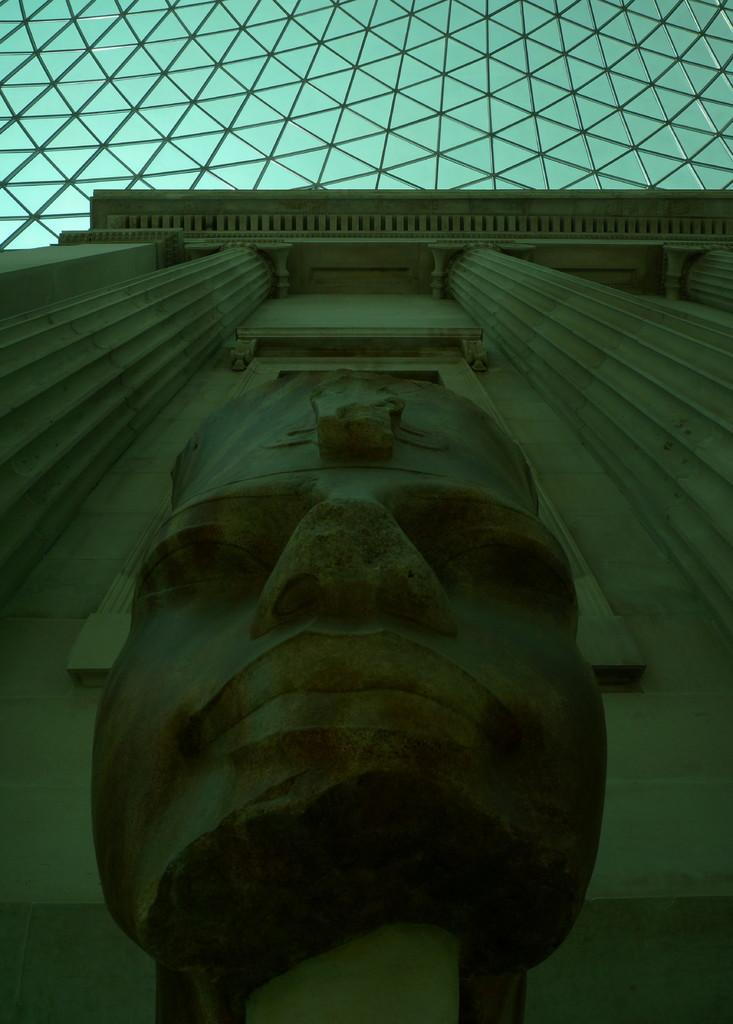What is the main subject in the middle of the image? There is a statue in the middle of the image. What material can be seen at the top of the image? There are metal rods at the top of the image. How many servants are present in the image? There are no servants present in the image. Is there a prison visible in the image? There is no prison visible in the image. 